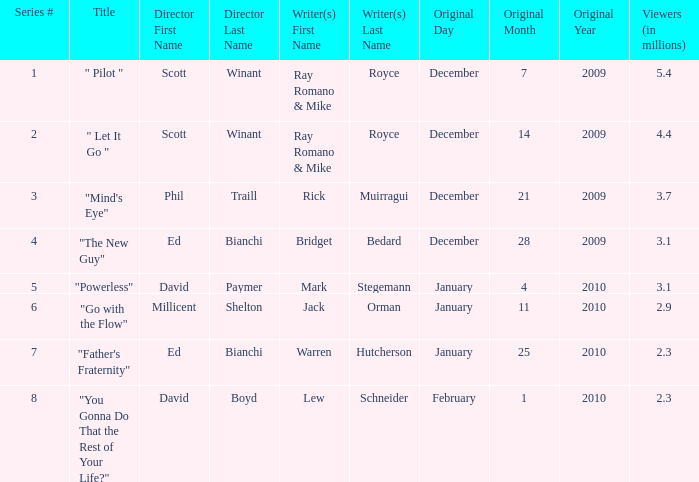When did the episode  "you gonna do that the rest of your life?" air? February1,2010. 